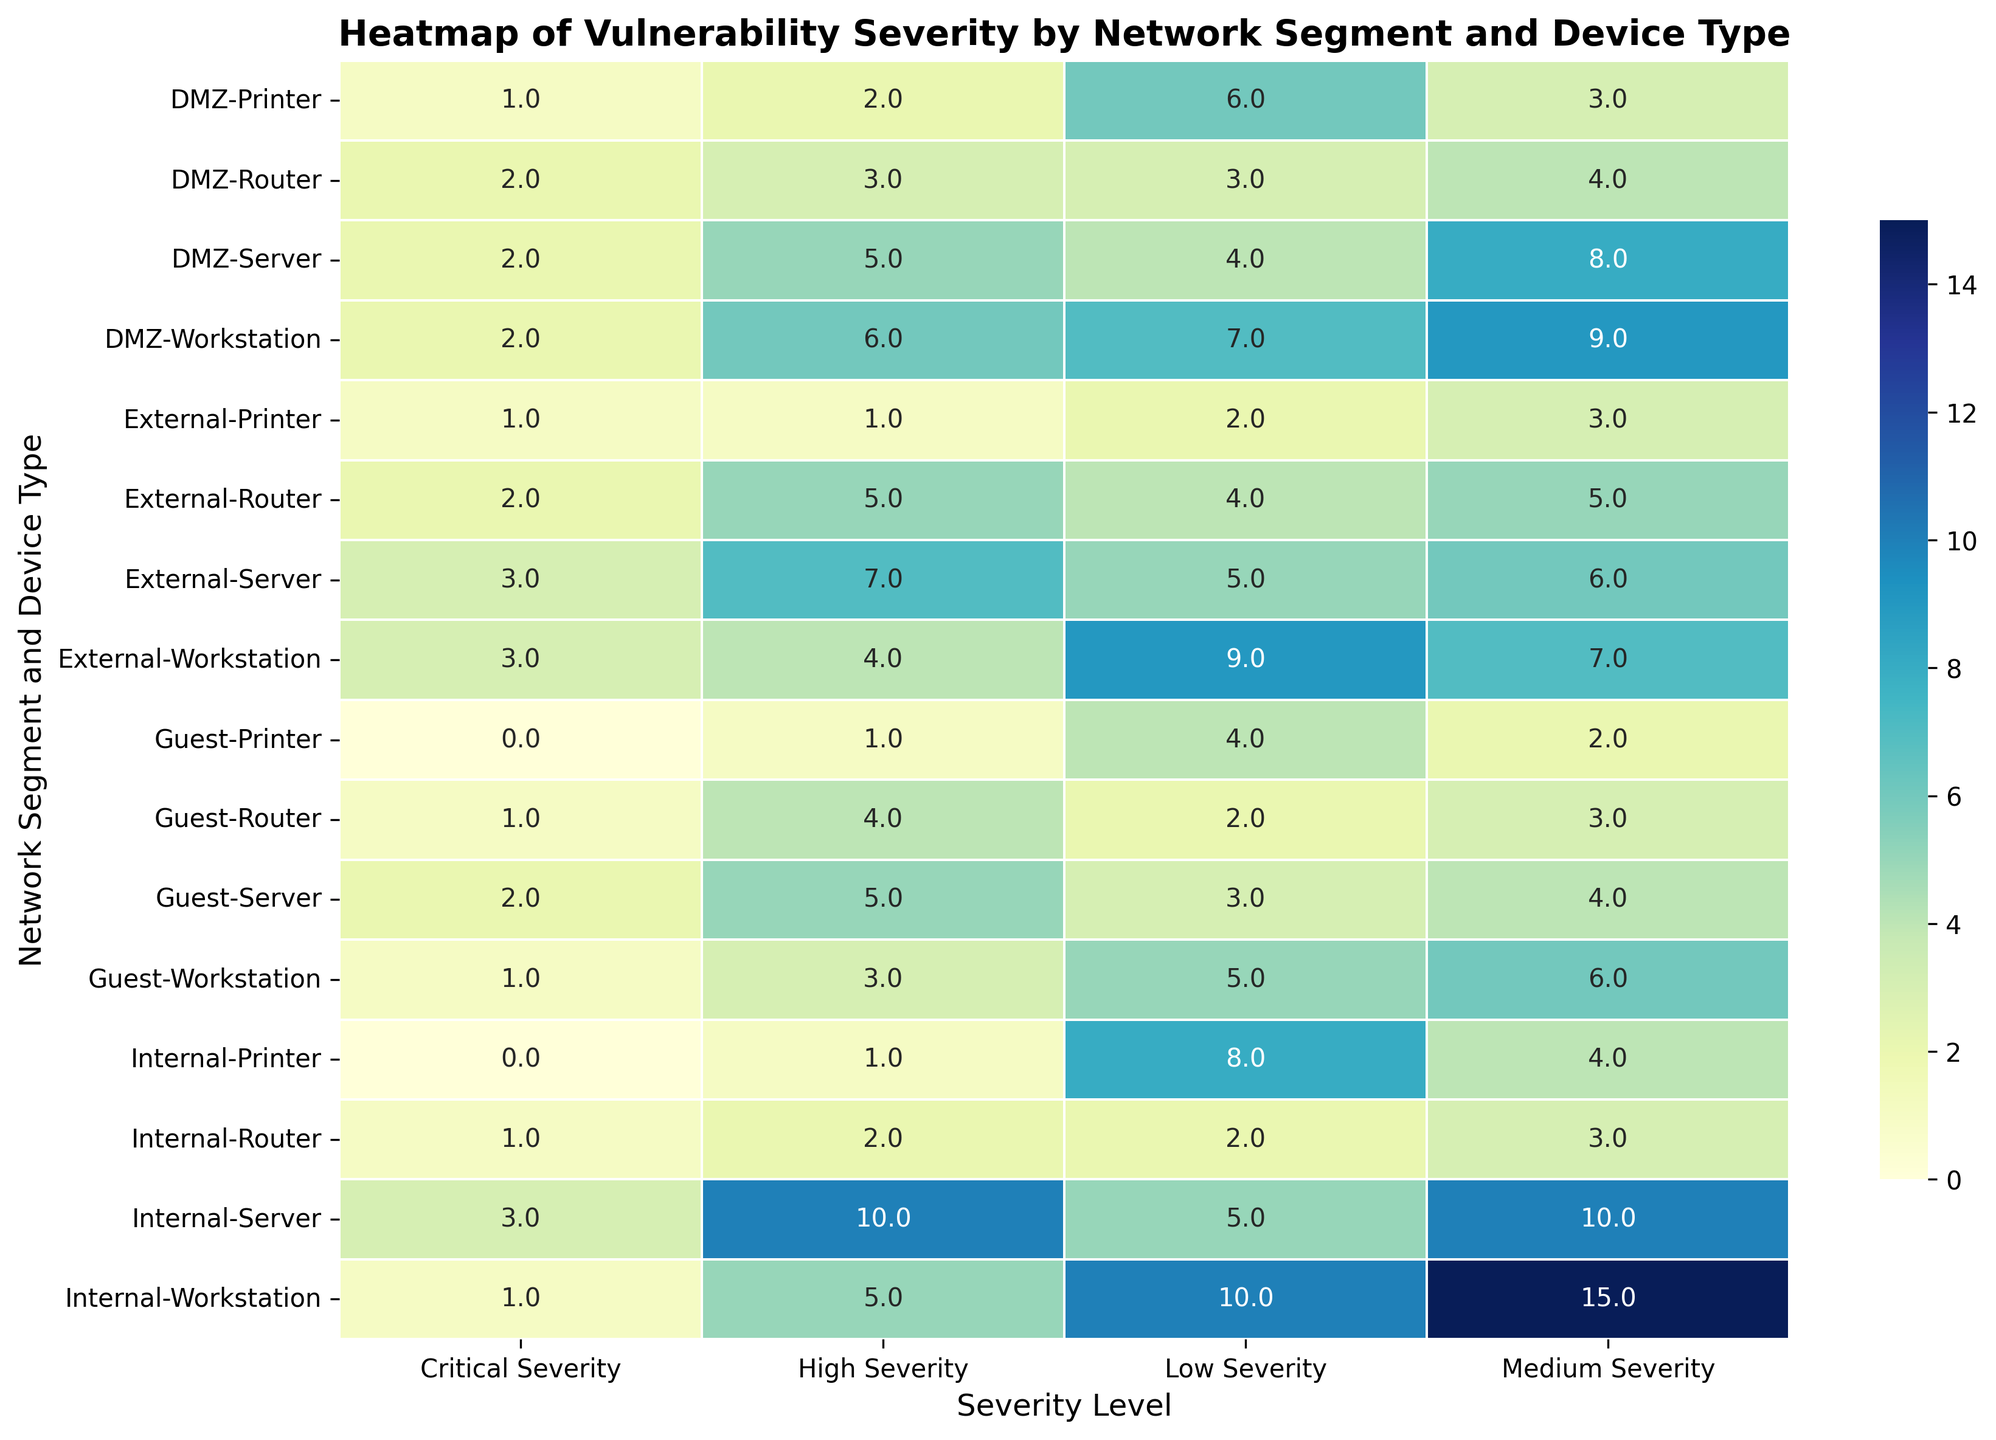What is the total number of critical severity vulnerabilities detected in the DMZ network segment? To find the total number of critical severity vulnerabilities in the DMZ segment, sum the values in the "Critical Severity" column for all device types within the DMZ. These values are 2 (Workstation) + 2 (Server) + 1 (Printer) + 2 (Router) = 7.
Answer: 7 Which device type in the Internal segment has the highest number of high severity vulnerabilities? Look at the "High Severity" column for the Internal network segment and compare the values for each device type. Workstations have 5, Servers have 10, Printers have 1, and Routers have 2. The Server has the highest number with 10.
Answer: Server How does the number of medium severity vulnerabilities in the External segment compare to the Guest segment for workstations? Compare the values in the "Medium Severity" column for workstations in both segments. External workstations have 7 medium severity vulnerabilities, and Guest workstations have 6. Thus, the External segment has 1 more medium severity vulnerability than the Guest segment.
Answer: External has 1 more Which network segment has the lowest number of low severity vulnerabilities across all device types? Sum the "Low Severity" values for all device types within each network segment. The sums are: Internal (10 + 5 + 8 + 2 = 25), DMZ (7 + 4 + 6 + 3 = 20), External (9 + 5 + 2 + 4 = 20), Guest (5 + 3 + 4 + 2 = 14). The Guest segment has the lowest total with 14.
Answer: Guest What is the average number of critical severity vulnerabilities detected across all network segments? To find the average, sum all values in the "Critical Severity" column and divide by the number of data points. The total is 1 (Internal Workstation) + 3 (Internal Server) + 0 (Internal Printer) + 1 (Internal Router) + 2 (DMZ Workstation) + 2 (DMZ Server) + 1 (DMZ Printer) + 2 (DMZ Router) + 3 (External Workstation) + 3 (External Server) + 1 (External Printer) + 2 (External Router) + 1 (Guest Workstation) + 2 (Guest Server) + 0 (Guest Printer) + 1 (Guest Router) = 25. There are 16 device types, so the average is 25 / 16 = 1.5625.
Answer: 1.5625 Which network segment and device type combination shows the highest count of medium severity vulnerabilities? Look at the "Medium Severity" column and identify the highest value across all combinations. The highest count is 15 which belongs to Internal Workstation.
Answer: Internal Workstation How many more high severity vulnerabilities are detected in DMZ Servers compared to DMZ Routers? Subtract the high severity count for DMZ Routers from that of DMZ Servers. DMZ Servers have 5, and DMZ Routers have 3. The difference is 5 - 3 = 2.
Answer: 2 In which segment and for which device type is the summation of low and critical severity vulnerabilities highest? Calculate the sum of "Low Severity" and "Critical Severity" for each combination: Internal Workstation (10 + 1 = 11), Internal Server (5 + 3 = 8), Internal Printer (8 + 0 = 8), Internal Router (2 + 1 = 3), DMZ Workstation (7 + 2 = 9), DMZ Server (4 + 2 = 6), DMZ Printer (6 + 1 = 7), DMZ Router (3 + 2 = 5), External Workstation (9 + 3 = 12), External Server (5 + 3 = 8), External Printer (2 + 1 = 3), External Router (4 + 2 = 6), Guest Workstation (5 + 1 = 6), Guest Server (3 + 2 = 5), Guest Printer (4 + 0 = 4), Guest Router (2 + 1 = 3). The highest is 12 for External Workstations.
Answer: External Workstation Which segment has the most balanced severity distribution across all device types? "Balanced" means nearly equal counts across all severity levels. Visual inspection suggests comparing values in each severity column for each segment. The DMZ segment has closer values across severity levels for most device types compared to other segments.
Answer: DMZ 